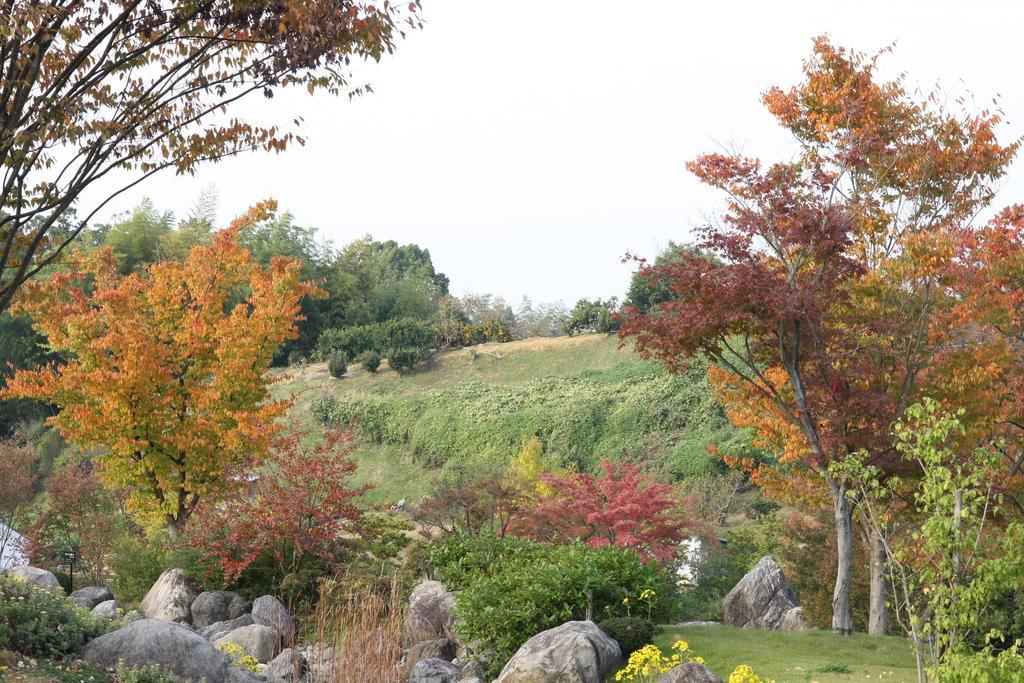Could you give a brief overview of what you see in this image? In this picture we can see a few rocks, plants and some grass on the ground. There are some trees on the left and right side of the image. 